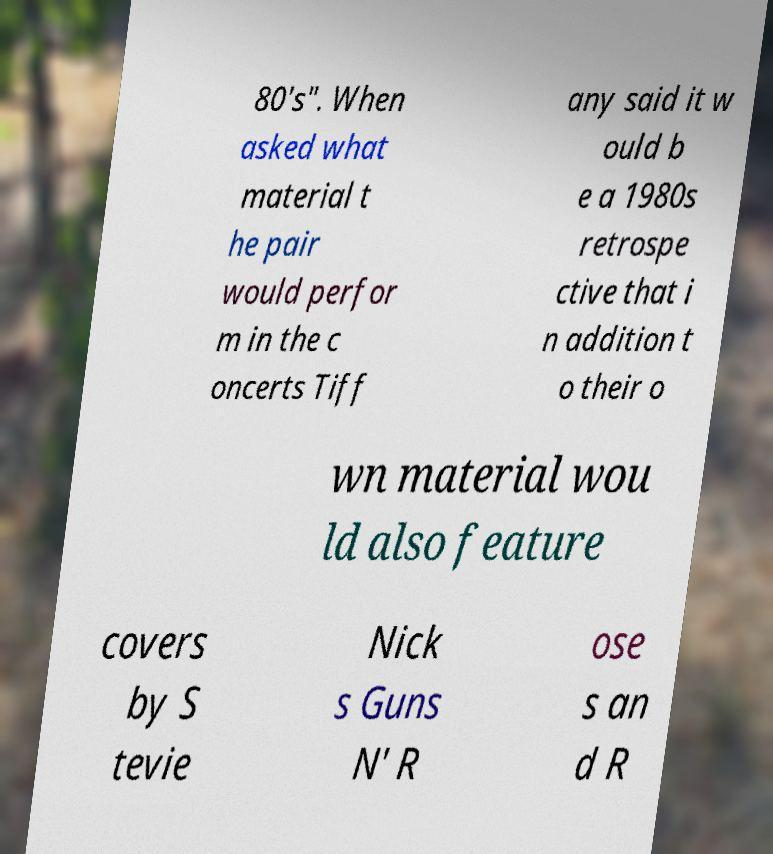Can you read and provide the text displayed in the image?This photo seems to have some interesting text. Can you extract and type it out for me? 80's". When asked what material t he pair would perfor m in the c oncerts Tiff any said it w ould b e a 1980s retrospe ctive that i n addition t o their o wn material wou ld also feature covers by S tevie Nick s Guns N' R ose s an d R 